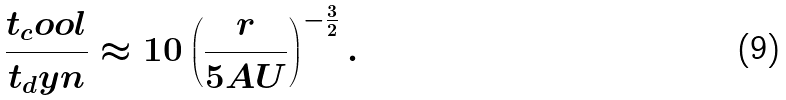<formula> <loc_0><loc_0><loc_500><loc_500>\frac { t _ { c } o o l } { t _ { d } y n } \approx 1 0 \left ( \frac { r } { 5 A U } \right ) ^ { - \frac { 3 } { 2 } } .</formula> 